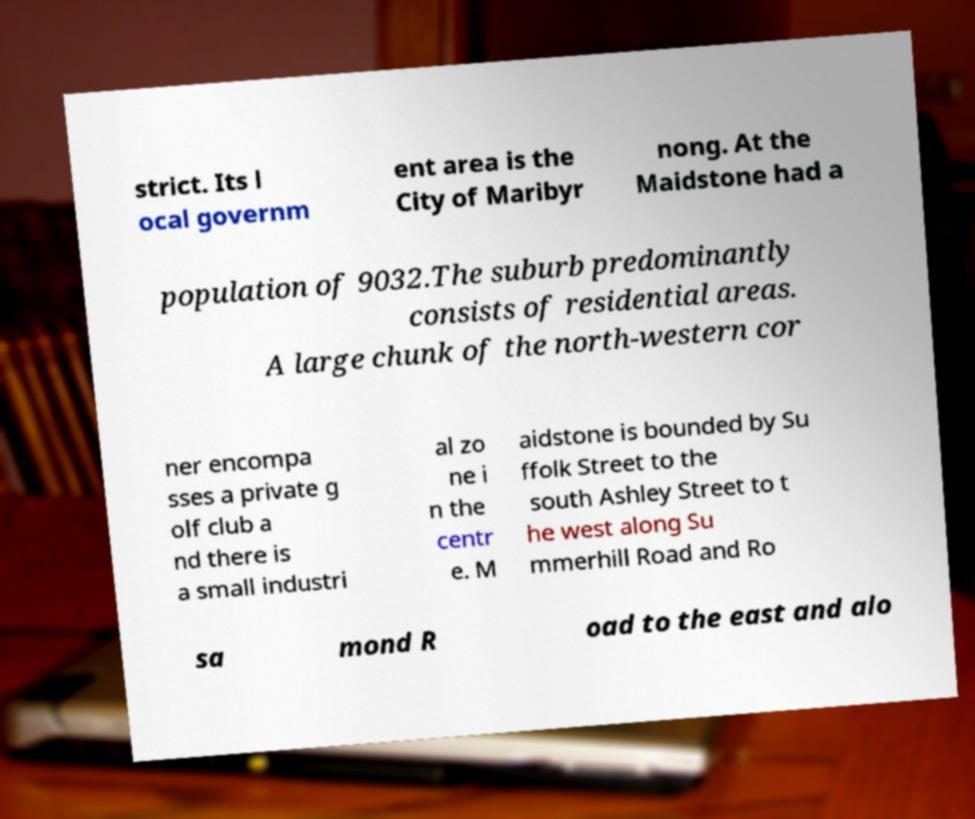Can you accurately transcribe the text from the provided image for me? strict. Its l ocal governm ent area is the City of Maribyr nong. At the Maidstone had a population of 9032.The suburb predominantly consists of residential areas. A large chunk of the north-western cor ner encompa sses a private g olf club a nd there is a small industri al zo ne i n the centr e. M aidstone is bounded by Su ffolk Street to the south Ashley Street to t he west along Su mmerhill Road and Ro sa mond R oad to the east and alo 